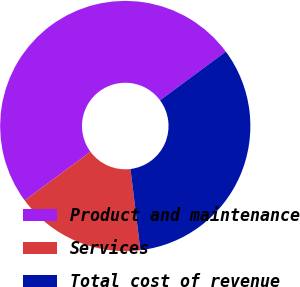<chart> <loc_0><loc_0><loc_500><loc_500><pie_chart><fcel>Product and maintenance<fcel>Services<fcel>Total cost of revenue<nl><fcel>50.0%<fcel>16.79%<fcel>33.21%<nl></chart> 